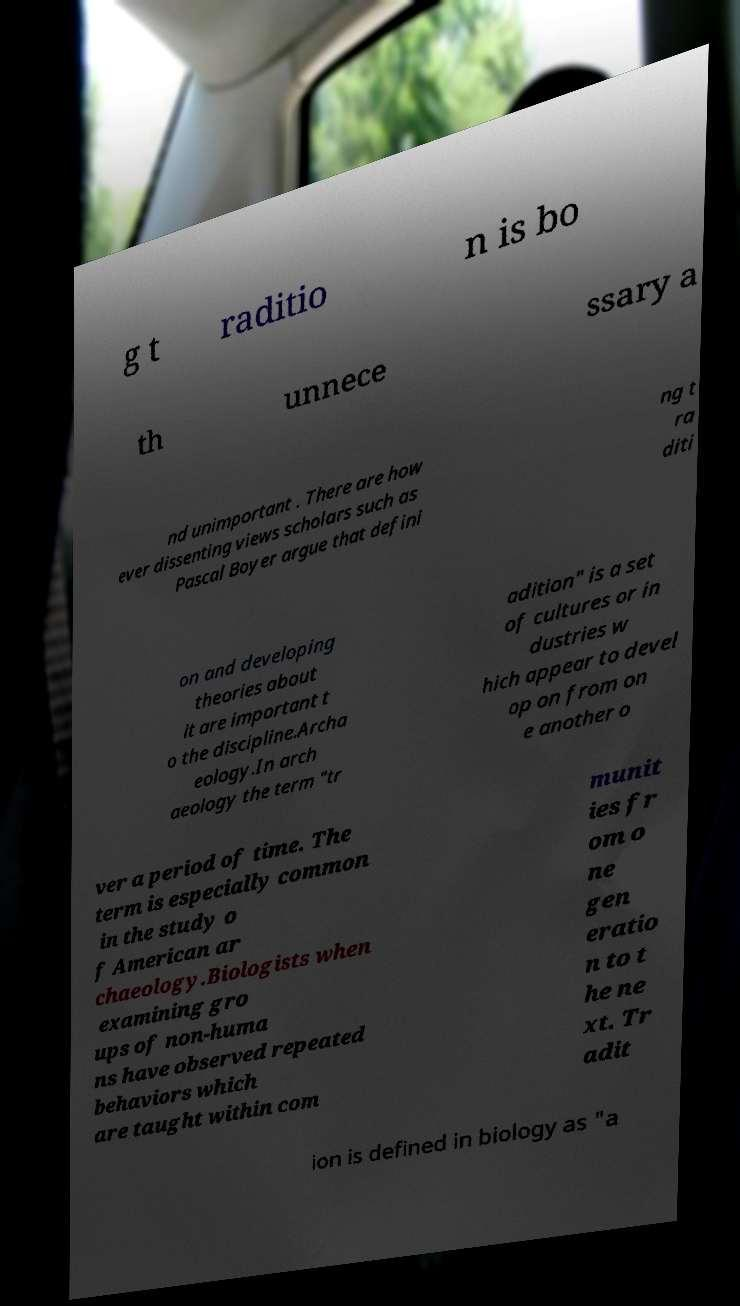Could you assist in decoding the text presented in this image and type it out clearly? g t raditio n is bo th unnece ssary a nd unimportant . There are how ever dissenting views scholars such as Pascal Boyer argue that defini ng t ra diti on and developing theories about it are important t o the discipline.Archa eology.In arch aeology the term "tr adition" is a set of cultures or in dustries w hich appear to devel op on from on e another o ver a period of time. The term is especially common in the study o f American ar chaeology.Biologists when examining gro ups of non-huma ns have observed repeated behaviors which are taught within com munit ies fr om o ne gen eratio n to t he ne xt. Tr adit ion is defined in biology as "a 